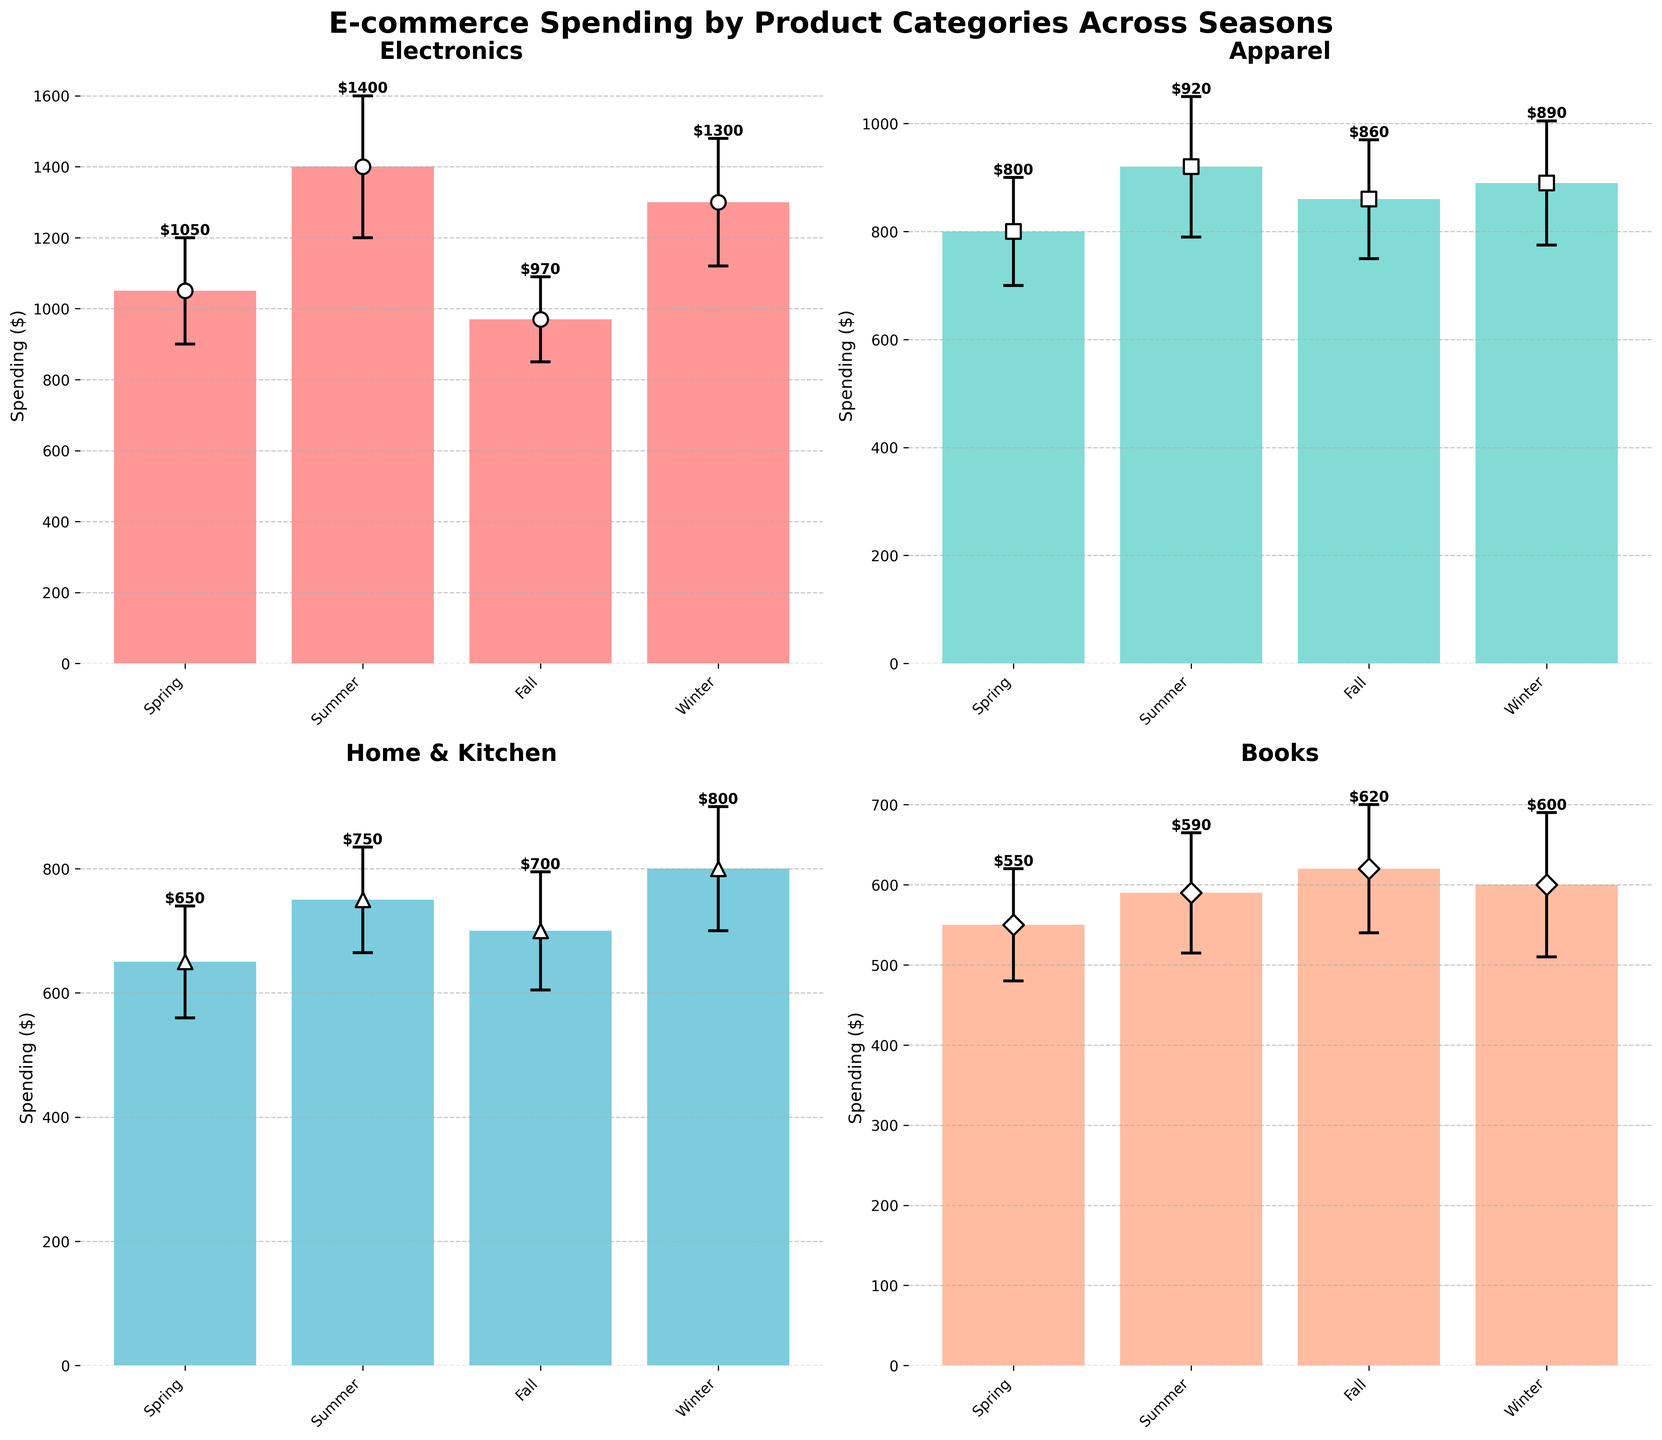What's the title of the figure? The title of the figure is written at the top and says "E-commerce Spending by Product Categories Across Seasons".
Answer: E-commerce Spending by Product Categories Across Seasons How many product categories are shown in the figure? The figure is divided into subplots, each representing a different product category. There are four subplots.
Answer: Four Which season shows the highest mean spending for Electronics? By looking at the Electronics subplot, the bar that is tallest corresponds to the Summer season.
Answer: Summer What is the average mean spending on Apparel across all seasons? To find the average mean spending on Apparel, we sum up the mean spending values for each season and divide by the number of seasons. That's (800 + 920 + 860 + 890) / 4.
Answer: 867.5 Which product category has the smallest standard deviation in Winter? To find this, compare the error bars (standard deviations) of Winter across all the subplots. Books have the smallest error bar in Winter.
Answer: Books How much more is the mean spending on Home & Kitchen in Winter compared to Spring? Subtract the mean spending value for Home & Kitchen in Spring from that in Winter: 800 - 650.
Answer: 150 In which season does the spending on Books have the most uncertainty? Uncertainty is depicted by the length of the error bars. The subplot for Books shows the longest error bar in Winter.
Answer: Winter Compare the mean spending on Electronics in Spring and Fall. Which is higher and by how much? Look at the heights of the Spring and Fall bars in the Electronics subplot. Spring (1050) is higher than Fall (970). The difference is 1050 - 970.
Answer: Spring by 80 Is the mean spending on Apparel in Summer closer to the spending in Spring or Winter? Compare the mean values: Summer (920), Spring (800), and Winter (890). Calculate the differences: 920 - 800 = 120 for Spring, 920 - 890 = 30 for Winter. Summer is closer to Winter.
Answer: Winter Which category shows the lowest mean spending in Summer? Look at the mean spending values for each category in the Summer subplots. Books have the lowest mean spending with 590.
Answer: Books 